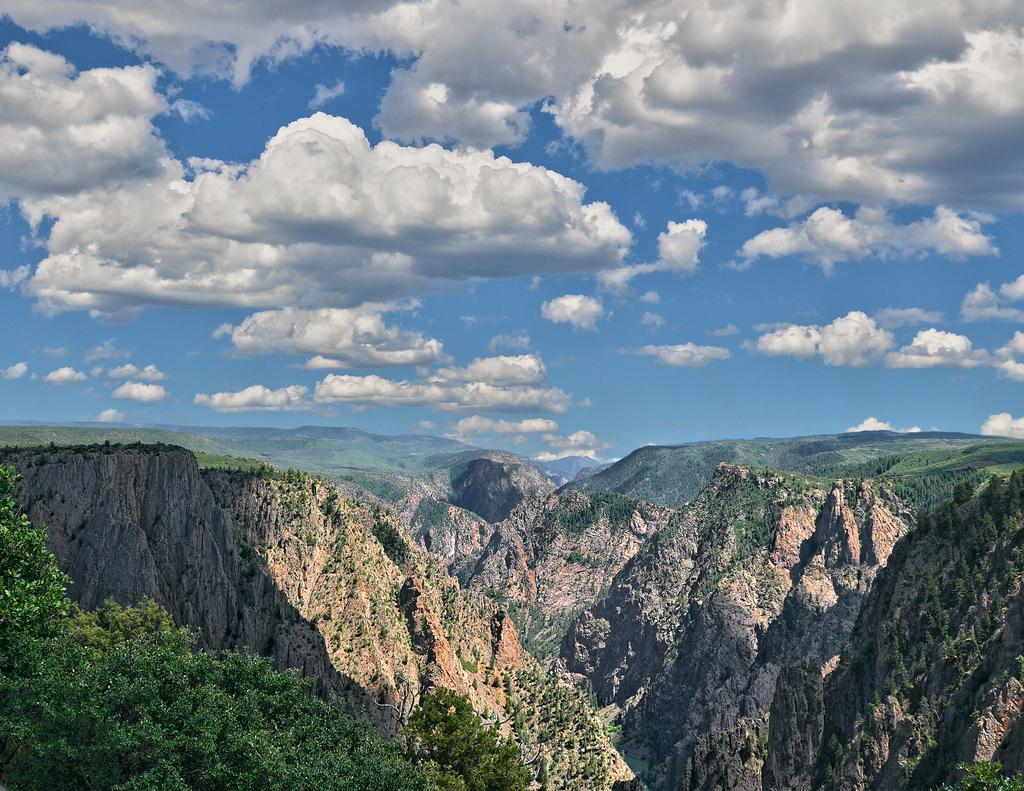Could you give a brief overview of what you see in this image? In this picture I can see trees, mountains, and in the background there is the sky. 